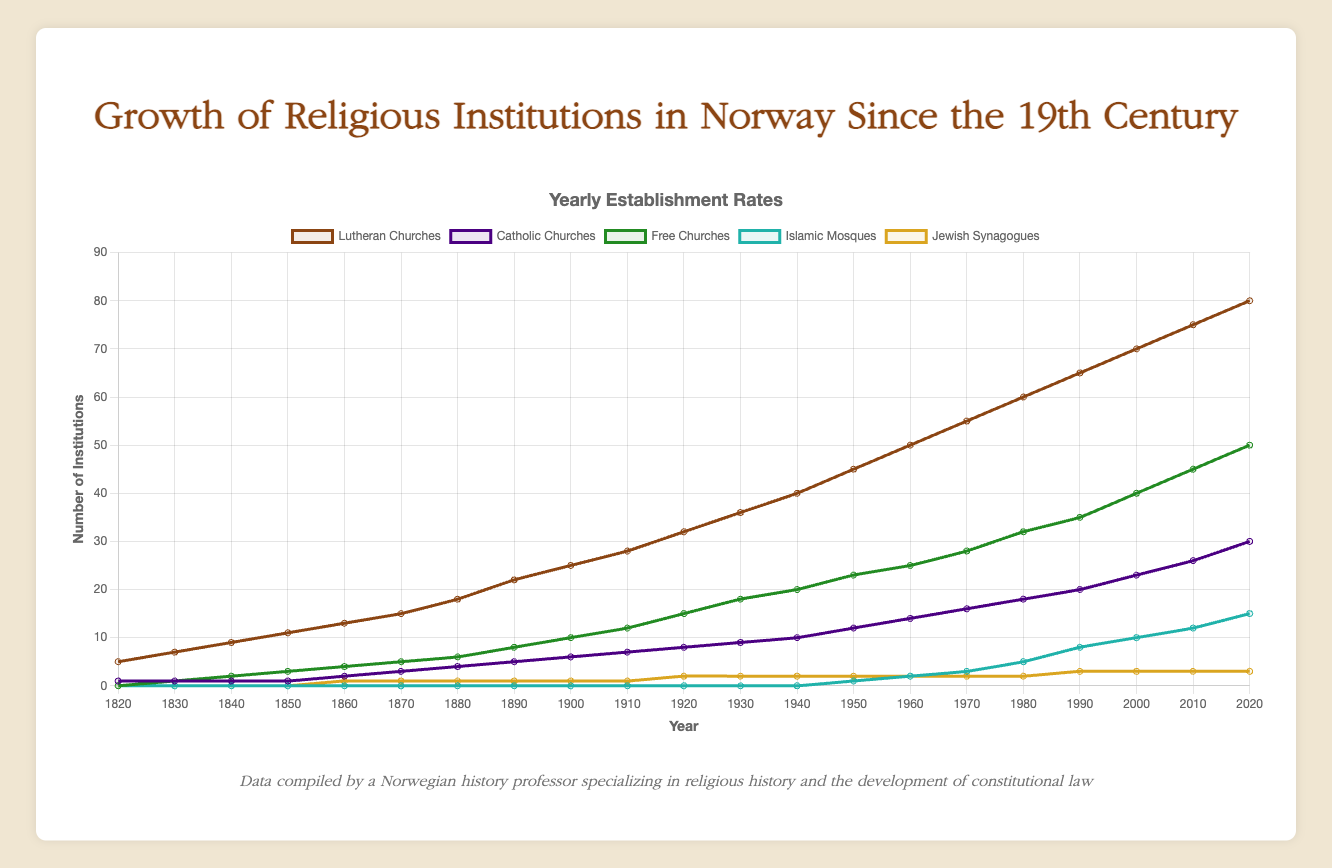How many Lutheran Churches were established by 1900? By 1900, the line plot for Lutheran Churches reaches 25, indicating that 25 Lutheran Churches were established by that year.
Answer: 25 Which religious institution experienced the highest growth rate between 1850 and 1920? To determine the highest growth rate, calculate the difference in the number of institutions between 1850 and 1920 for each group. Lutheran Churches increased from 11 to 32 (21), Catholic Churches from 1 to 8 (7), Free Churches from 3 to 15 (12), Islamic Mosques from 0 to 0 (0), and Jewish Synagogues from 0 to 2 (2). Thus, Lutheran Churches experienced the highest growth rate.
Answer: Lutheran Churches In which decade did Islamic Mosques first appear, and how many were there by the end of that decade? Observing the plot, Islamic Mosques first appear in 1950, with the line indicating they reached a value of 1 by the end of that decade.
Answer: 1950, 1 Which religious group had a constant rate of establishment from 1820 to 1890? To find a constant establishment rate, check if the increase per decade is steady. Lutheran Churches increased steadily each decade; hence, they had a constant establishment rate.
Answer: Lutheran Churches What is the total number of institutions established for Free Churches and Islamic Mosques by 2020? Sum the values for Free Churches and Islamic Mosques in 2020 from the plot: Free Churches (50) + Islamic Mosques (15) = 65 institutions.
Answer: 65 Between which two decades did Jewish Synagogues see their first increase, and by how much did they increase? Jewish Synagogues first increased between 1850 and 1860, from 0 to 1, indicating an increase of 1.
Answer: 1850-1860, 1 Compare the number of Catholic Churches and Free Churches in 1980. Which group had more establishments, and by how much? In 1980, Catholic Churches had 18 establishments and Free Churches had 32. Free Churches had more establishments by 14.
Answer: Free Churches, 14 What is the average number of establishments for Lutheran Churches from 1820 to 1920? Add the values from 1820 to 1920 for Lutheran Churches (5, 7, 9, 11, 13, 15, 18, 22, 25, 28, 32) and divide by 11: (5+7+9+11+13+15+18+22+25+28+32)/11 = 17.
Answer: 17 How does the establishment of Jewish Synagogues in 1950 compare to that in 2020? In 1950, there were 2 Jewish Synagogues, and by 2020, there were 3, indicating an increase of 1.
Answer: Increased by 1 What color represents the line for Islamic Mosques, and what is their starting establishment year? The line for Islamic Mosques is represented by a light blue color, and they started in the year 1950.
Answer: Light blue, 1950 